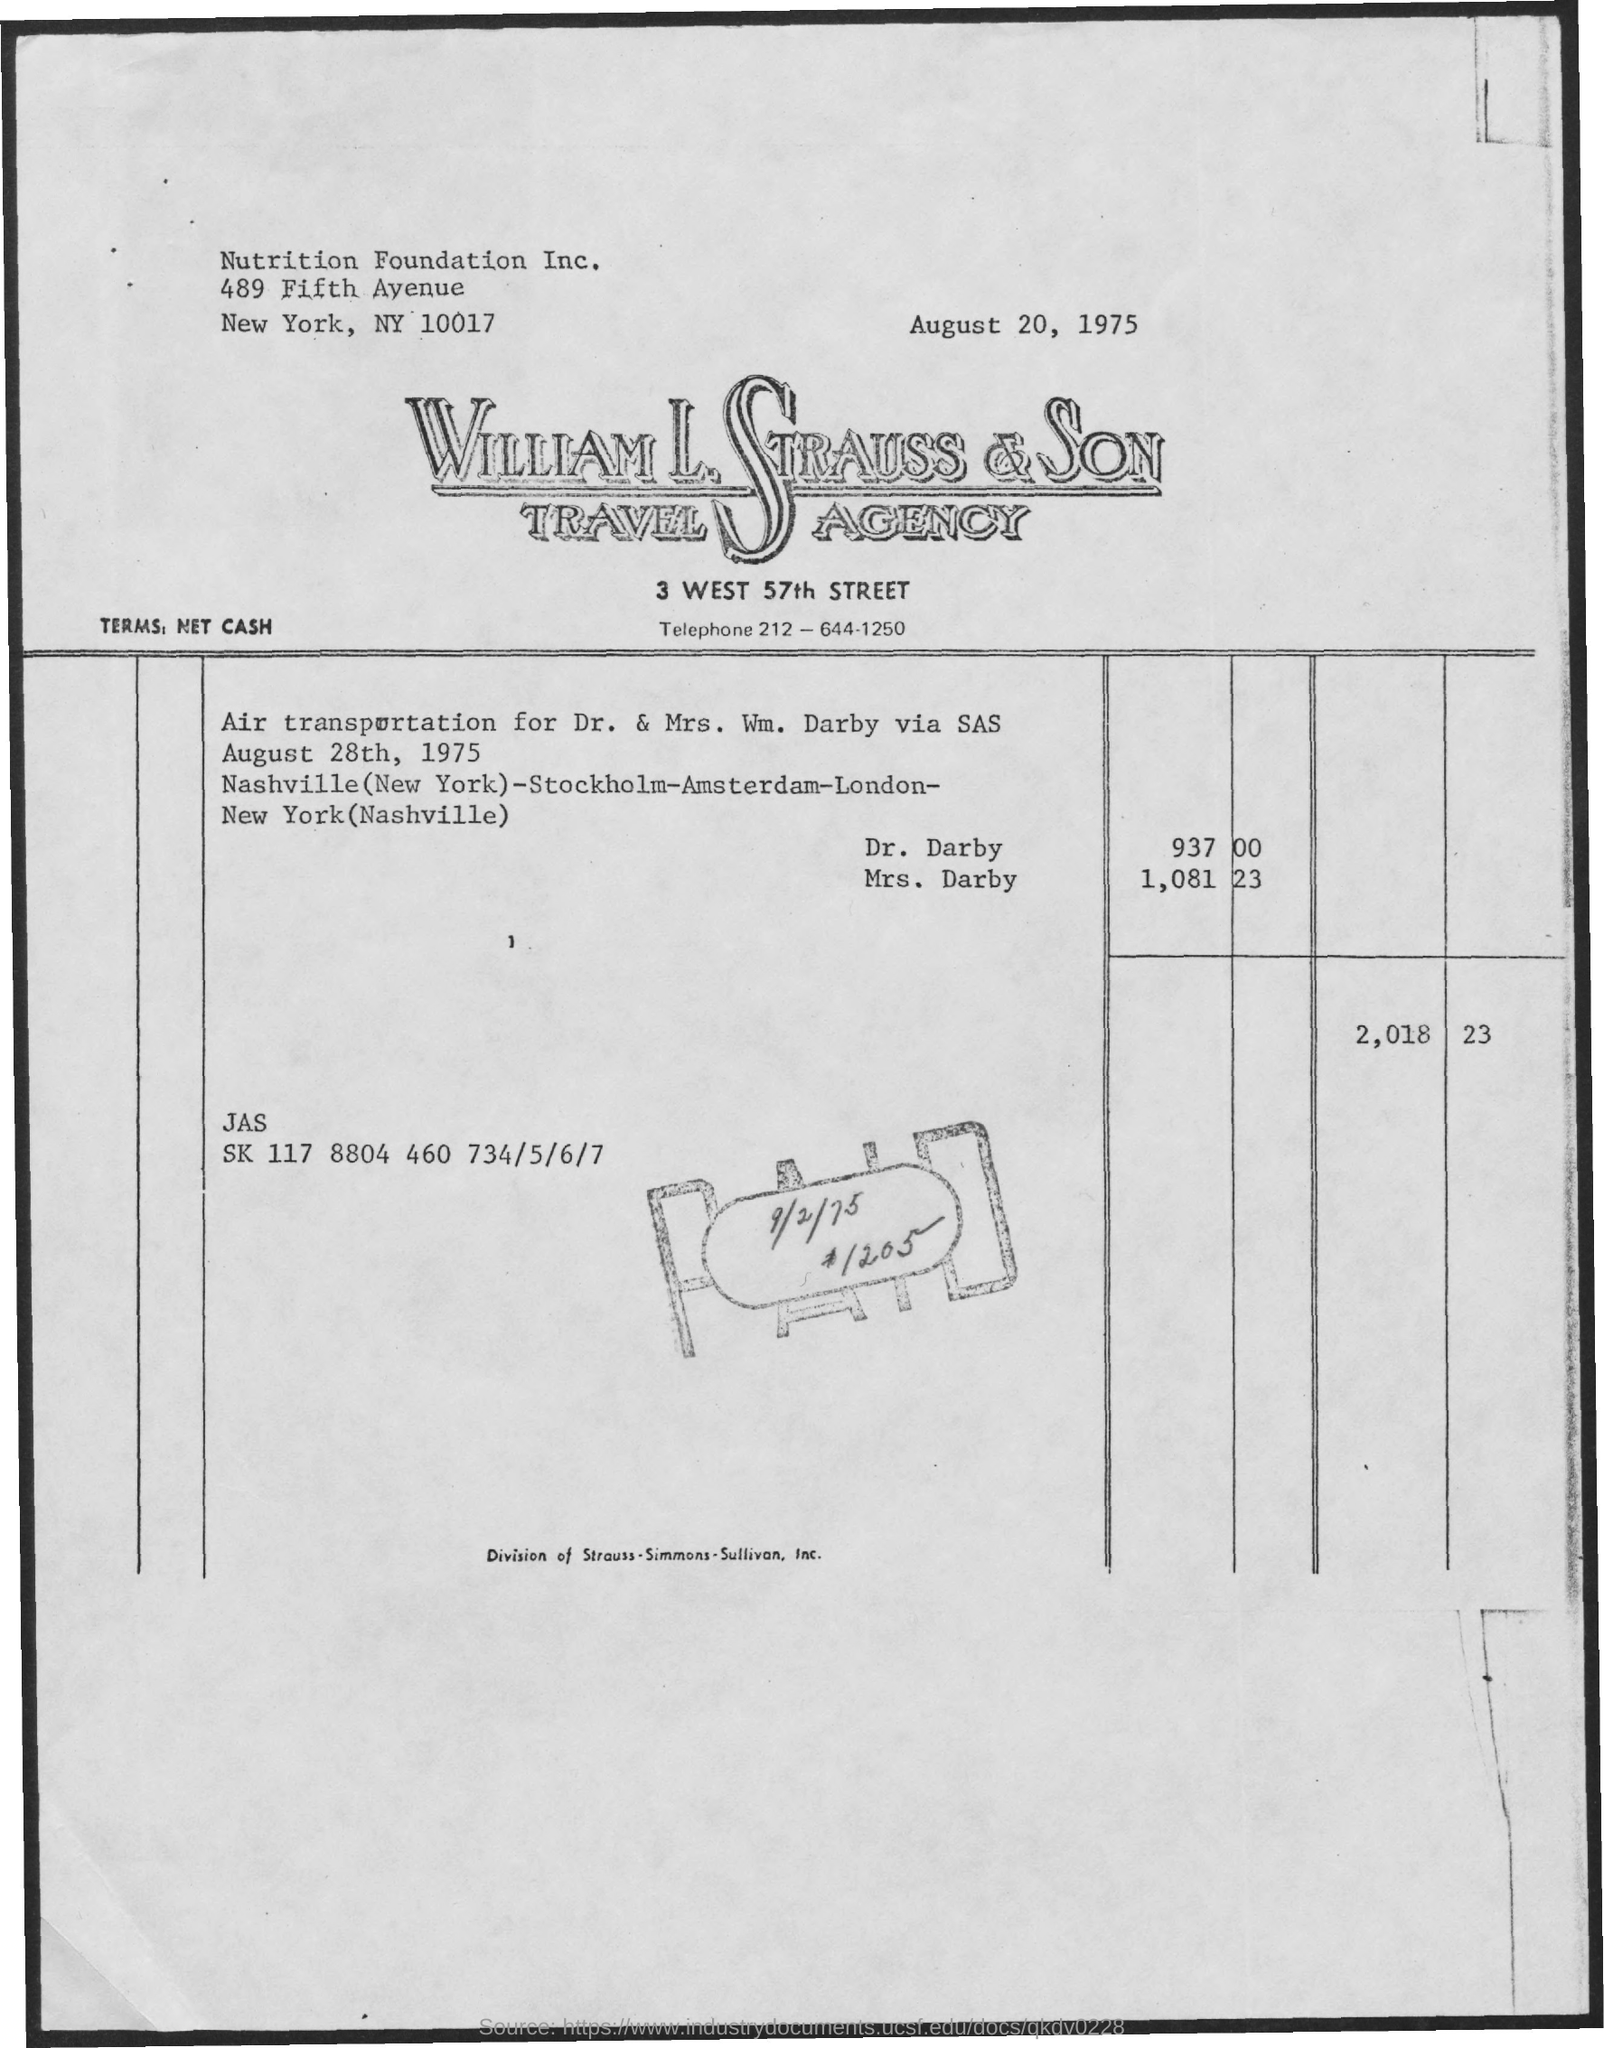Mention a couple of crucial points in this snapshot. The date displayed at the top right corner of the document is August 20, 1975. The William L. Strauss & Son Travel Agency belongs to the company to which this letterhead belongs. 